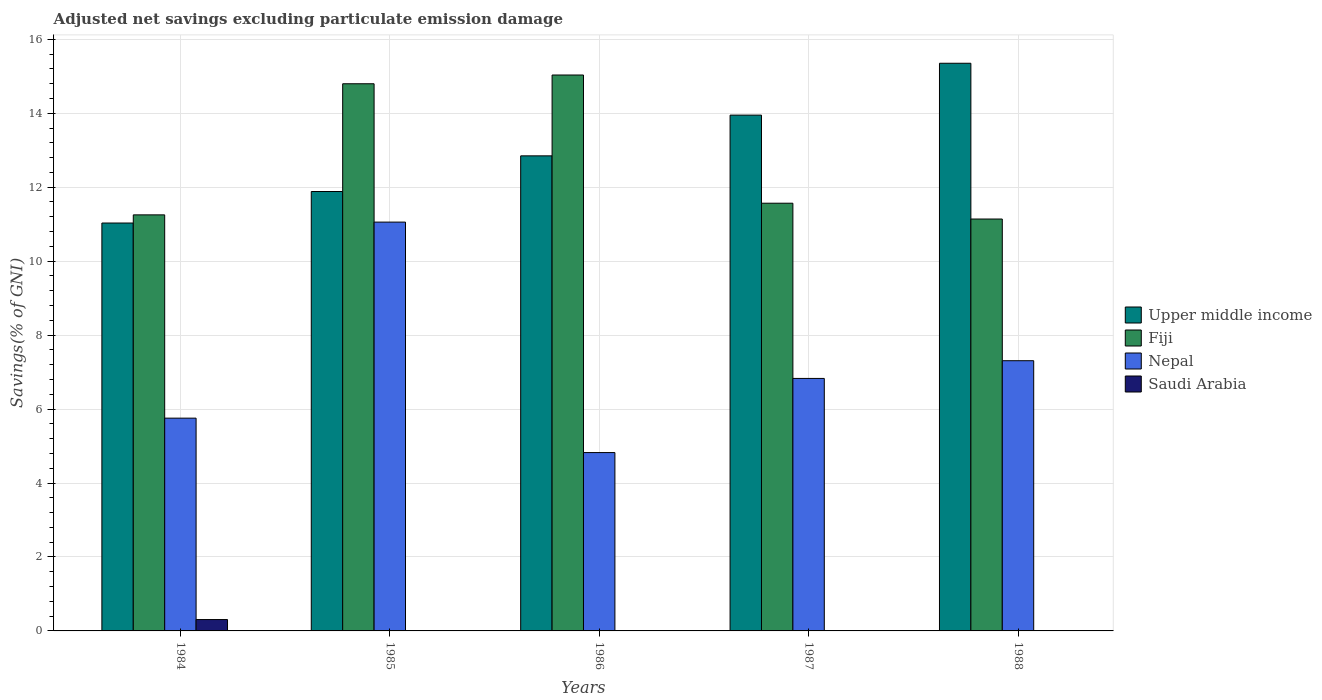How many groups of bars are there?
Give a very brief answer. 5. Are the number of bars per tick equal to the number of legend labels?
Offer a very short reply. No. Are the number of bars on each tick of the X-axis equal?
Keep it short and to the point. No. In how many cases, is the number of bars for a given year not equal to the number of legend labels?
Ensure brevity in your answer.  4. What is the adjusted net savings in Fiji in 1988?
Provide a succinct answer. 11.14. Across all years, what is the maximum adjusted net savings in Fiji?
Your response must be concise. 15.03. Across all years, what is the minimum adjusted net savings in Nepal?
Your answer should be compact. 4.82. In which year was the adjusted net savings in Nepal maximum?
Ensure brevity in your answer.  1985. What is the total adjusted net savings in Fiji in the graph?
Your answer should be very brief. 63.79. What is the difference between the adjusted net savings in Nepal in 1985 and that in 1988?
Provide a short and direct response. 3.75. What is the difference between the adjusted net savings in Saudi Arabia in 1986 and the adjusted net savings in Nepal in 1987?
Offer a very short reply. -6.83. What is the average adjusted net savings in Nepal per year?
Your answer should be compact. 7.15. In the year 1986, what is the difference between the adjusted net savings in Nepal and adjusted net savings in Upper middle income?
Your answer should be compact. -8.02. In how many years, is the adjusted net savings in Upper middle income greater than 11.6 %?
Your answer should be very brief. 4. What is the ratio of the adjusted net savings in Upper middle income in 1984 to that in 1988?
Ensure brevity in your answer.  0.72. Is the difference between the adjusted net savings in Nepal in 1985 and 1988 greater than the difference between the adjusted net savings in Upper middle income in 1985 and 1988?
Keep it short and to the point. Yes. What is the difference between the highest and the second highest adjusted net savings in Nepal?
Provide a short and direct response. 3.75. What is the difference between the highest and the lowest adjusted net savings in Upper middle income?
Provide a succinct answer. 4.32. Is the sum of the adjusted net savings in Upper middle income in 1985 and 1986 greater than the maximum adjusted net savings in Nepal across all years?
Ensure brevity in your answer.  Yes. How many bars are there?
Give a very brief answer. 16. Are all the bars in the graph horizontal?
Keep it short and to the point. No. What is the difference between two consecutive major ticks on the Y-axis?
Provide a succinct answer. 2. Does the graph contain grids?
Offer a very short reply. Yes. Where does the legend appear in the graph?
Provide a short and direct response. Center right. How many legend labels are there?
Make the answer very short. 4. What is the title of the graph?
Offer a very short reply. Adjusted net savings excluding particulate emission damage. Does "Sao Tome and Principe" appear as one of the legend labels in the graph?
Offer a terse response. No. What is the label or title of the Y-axis?
Your answer should be compact. Savings(% of GNI). What is the Savings(% of GNI) of Upper middle income in 1984?
Your answer should be very brief. 11.03. What is the Savings(% of GNI) in Fiji in 1984?
Keep it short and to the point. 11.25. What is the Savings(% of GNI) of Nepal in 1984?
Your response must be concise. 5.75. What is the Savings(% of GNI) in Saudi Arabia in 1984?
Offer a terse response. 0.31. What is the Savings(% of GNI) in Upper middle income in 1985?
Ensure brevity in your answer.  11.88. What is the Savings(% of GNI) of Fiji in 1985?
Provide a succinct answer. 14.8. What is the Savings(% of GNI) in Nepal in 1985?
Ensure brevity in your answer.  11.06. What is the Savings(% of GNI) of Saudi Arabia in 1985?
Ensure brevity in your answer.  0. What is the Savings(% of GNI) in Upper middle income in 1986?
Give a very brief answer. 12.85. What is the Savings(% of GNI) of Fiji in 1986?
Offer a terse response. 15.03. What is the Savings(% of GNI) in Nepal in 1986?
Give a very brief answer. 4.82. What is the Savings(% of GNI) in Saudi Arabia in 1986?
Provide a short and direct response. 0. What is the Savings(% of GNI) in Upper middle income in 1987?
Keep it short and to the point. 13.95. What is the Savings(% of GNI) in Fiji in 1987?
Provide a succinct answer. 11.57. What is the Savings(% of GNI) in Nepal in 1987?
Keep it short and to the point. 6.83. What is the Savings(% of GNI) of Upper middle income in 1988?
Offer a very short reply. 15.35. What is the Savings(% of GNI) in Fiji in 1988?
Your answer should be compact. 11.14. What is the Savings(% of GNI) in Nepal in 1988?
Provide a succinct answer. 7.31. What is the Savings(% of GNI) in Saudi Arabia in 1988?
Your answer should be compact. 0. Across all years, what is the maximum Savings(% of GNI) in Upper middle income?
Your response must be concise. 15.35. Across all years, what is the maximum Savings(% of GNI) of Fiji?
Provide a short and direct response. 15.03. Across all years, what is the maximum Savings(% of GNI) of Nepal?
Your answer should be very brief. 11.06. Across all years, what is the maximum Savings(% of GNI) of Saudi Arabia?
Ensure brevity in your answer.  0.31. Across all years, what is the minimum Savings(% of GNI) in Upper middle income?
Give a very brief answer. 11.03. Across all years, what is the minimum Savings(% of GNI) of Fiji?
Your response must be concise. 11.14. Across all years, what is the minimum Savings(% of GNI) of Nepal?
Your answer should be very brief. 4.82. Across all years, what is the minimum Savings(% of GNI) of Saudi Arabia?
Keep it short and to the point. 0. What is the total Savings(% of GNI) of Upper middle income in the graph?
Keep it short and to the point. 65.07. What is the total Savings(% of GNI) in Fiji in the graph?
Your answer should be very brief. 63.79. What is the total Savings(% of GNI) in Nepal in the graph?
Make the answer very short. 35.77. What is the total Savings(% of GNI) of Saudi Arabia in the graph?
Provide a short and direct response. 0.31. What is the difference between the Savings(% of GNI) of Upper middle income in 1984 and that in 1985?
Offer a very short reply. -0.85. What is the difference between the Savings(% of GNI) of Fiji in 1984 and that in 1985?
Offer a terse response. -3.55. What is the difference between the Savings(% of GNI) of Nepal in 1984 and that in 1985?
Provide a short and direct response. -5.3. What is the difference between the Savings(% of GNI) of Upper middle income in 1984 and that in 1986?
Your response must be concise. -1.82. What is the difference between the Savings(% of GNI) of Fiji in 1984 and that in 1986?
Offer a very short reply. -3.78. What is the difference between the Savings(% of GNI) in Nepal in 1984 and that in 1986?
Keep it short and to the point. 0.93. What is the difference between the Savings(% of GNI) in Upper middle income in 1984 and that in 1987?
Ensure brevity in your answer.  -2.92. What is the difference between the Savings(% of GNI) of Fiji in 1984 and that in 1987?
Offer a very short reply. -0.32. What is the difference between the Savings(% of GNI) of Nepal in 1984 and that in 1987?
Your answer should be very brief. -1.07. What is the difference between the Savings(% of GNI) in Upper middle income in 1984 and that in 1988?
Give a very brief answer. -4.32. What is the difference between the Savings(% of GNI) in Fiji in 1984 and that in 1988?
Provide a short and direct response. 0.11. What is the difference between the Savings(% of GNI) in Nepal in 1984 and that in 1988?
Make the answer very short. -1.55. What is the difference between the Savings(% of GNI) in Upper middle income in 1985 and that in 1986?
Give a very brief answer. -0.96. What is the difference between the Savings(% of GNI) in Fiji in 1985 and that in 1986?
Your answer should be very brief. -0.24. What is the difference between the Savings(% of GNI) in Nepal in 1985 and that in 1986?
Give a very brief answer. 6.23. What is the difference between the Savings(% of GNI) of Upper middle income in 1985 and that in 1987?
Provide a short and direct response. -2.07. What is the difference between the Savings(% of GNI) in Fiji in 1985 and that in 1987?
Your answer should be compact. 3.23. What is the difference between the Savings(% of GNI) in Nepal in 1985 and that in 1987?
Offer a terse response. 4.23. What is the difference between the Savings(% of GNI) of Upper middle income in 1985 and that in 1988?
Your response must be concise. -3.47. What is the difference between the Savings(% of GNI) in Fiji in 1985 and that in 1988?
Your answer should be very brief. 3.66. What is the difference between the Savings(% of GNI) of Nepal in 1985 and that in 1988?
Your answer should be compact. 3.75. What is the difference between the Savings(% of GNI) of Upper middle income in 1986 and that in 1987?
Your answer should be very brief. -1.1. What is the difference between the Savings(% of GNI) of Fiji in 1986 and that in 1987?
Your answer should be compact. 3.47. What is the difference between the Savings(% of GNI) in Nepal in 1986 and that in 1987?
Ensure brevity in your answer.  -2.01. What is the difference between the Savings(% of GNI) of Upper middle income in 1986 and that in 1988?
Keep it short and to the point. -2.5. What is the difference between the Savings(% of GNI) of Fiji in 1986 and that in 1988?
Provide a short and direct response. 3.89. What is the difference between the Savings(% of GNI) of Nepal in 1986 and that in 1988?
Your answer should be compact. -2.48. What is the difference between the Savings(% of GNI) in Upper middle income in 1987 and that in 1988?
Your answer should be compact. -1.4. What is the difference between the Savings(% of GNI) of Fiji in 1987 and that in 1988?
Ensure brevity in your answer.  0.43. What is the difference between the Savings(% of GNI) in Nepal in 1987 and that in 1988?
Offer a terse response. -0.48. What is the difference between the Savings(% of GNI) of Upper middle income in 1984 and the Savings(% of GNI) of Fiji in 1985?
Your answer should be very brief. -3.77. What is the difference between the Savings(% of GNI) in Upper middle income in 1984 and the Savings(% of GNI) in Nepal in 1985?
Your answer should be compact. -0.02. What is the difference between the Savings(% of GNI) in Fiji in 1984 and the Savings(% of GNI) in Nepal in 1985?
Provide a succinct answer. 0.2. What is the difference between the Savings(% of GNI) in Upper middle income in 1984 and the Savings(% of GNI) in Fiji in 1986?
Your response must be concise. -4. What is the difference between the Savings(% of GNI) of Upper middle income in 1984 and the Savings(% of GNI) of Nepal in 1986?
Your response must be concise. 6.21. What is the difference between the Savings(% of GNI) in Fiji in 1984 and the Savings(% of GNI) in Nepal in 1986?
Offer a very short reply. 6.43. What is the difference between the Savings(% of GNI) in Upper middle income in 1984 and the Savings(% of GNI) in Fiji in 1987?
Offer a very short reply. -0.54. What is the difference between the Savings(% of GNI) in Upper middle income in 1984 and the Savings(% of GNI) in Nepal in 1987?
Your answer should be compact. 4.2. What is the difference between the Savings(% of GNI) of Fiji in 1984 and the Savings(% of GNI) of Nepal in 1987?
Provide a short and direct response. 4.42. What is the difference between the Savings(% of GNI) of Upper middle income in 1984 and the Savings(% of GNI) of Fiji in 1988?
Provide a short and direct response. -0.11. What is the difference between the Savings(% of GNI) in Upper middle income in 1984 and the Savings(% of GNI) in Nepal in 1988?
Your answer should be very brief. 3.72. What is the difference between the Savings(% of GNI) of Fiji in 1984 and the Savings(% of GNI) of Nepal in 1988?
Your answer should be compact. 3.94. What is the difference between the Savings(% of GNI) in Upper middle income in 1985 and the Savings(% of GNI) in Fiji in 1986?
Provide a short and direct response. -3.15. What is the difference between the Savings(% of GNI) of Upper middle income in 1985 and the Savings(% of GNI) of Nepal in 1986?
Give a very brief answer. 7.06. What is the difference between the Savings(% of GNI) of Fiji in 1985 and the Savings(% of GNI) of Nepal in 1986?
Offer a very short reply. 9.97. What is the difference between the Savings(% of GNI) in Upper middle income in 1985 and the Savings(% of GNI) in Fiji in 1987?
Offer a terse response. 0.32. What is the difference between the Savings(% of GNI) in Upper middle income in 1985 and the Savings(% of GNI) in Nepal in 1987?
Your answer should be compact. 5.06. What is the difference between the Savings(% of GNI) of Fiji in 1985 and the Savings(% of GNI) of Nepal in 1987?
Ensure brevity in your answer.  7.97. What is the difference between the Savings(% of GNI) of Upper middle income in 1985 and the Savings(% of GNI) of Fiji in 1988?
Your answer should be very brief. 0.74. What is the difference between the Savings(% of GNI) of Upper middle income in 1985 and the Savings(% of GNI) of Nepal in 1988?
Provide a short and direct response. 4.58. What is the difference between the Savings(% of GNI) in Fiji in 1985 and the Savings(% of GNI) in Nepal in 1988?
Keep it short and to the point. 7.49. What is the difference between the Savings(% of GNI) in Upper middle income in 1986 and the Savings(% of GNI) in Fiji in 1987?
Give a very brief answer. 1.28. What is the difference between the Savings(% of GNI) in Upper middle income in 1986 and the Savings(% of GNI) in Nepal in 1987?
Keep it short and to the point. 6.02. What is the difference between the Savings(% of GNI) of Fiji in 1986 and the Savings(% of GNI) of Nepal in 1987?
Provide a short and direct response. 8.21. What is the difference between the Savings(% of GNI) of Upper middle income in 1986 and the Savings(% of GNI) of Fiji in 1988?
Provide a succinct answer. 1.71. What is the difference between the Savings(% of GNI) of Upper middle income in 1986 and the Savings(% of GNI) of Nepal in 1988?
Provide a short and direct response. 5.54. What is the difference between the Savings(% of GNI) in Fiji in 1986 and the Savings(% of GNI) in Nepal in 1988?
Your answer should be compact. 7.73. What is the difference between the Savings(% of GNI) in Upper middle income in 1987 and the Savings(% of GNI) in Fiji in 1988?
Your answer should be compact. 2.81. What is the difference between the Savings(% of GNI) in Upper middle income in 1987 and the Savings(% of GNI) in Nepal in 1988?
Ensure brevity in your answer.  6.64. What is the difference between the Savings(% of GNI) of Fiji in 1987 and the Savings(% of GNI) of Nepal in 1988?
Your answer should be very brief. 4.26. What is the average Savings(% of GNI) in Upper middle income per year?
Ensure brevity in your answer.  13.01. What is the average Savings(% of GNI) of Fiji per year?
Your answer should be compact. 12.76. What is the average Savings(% of GNI) of Nepal per year?
Your answer should be compact. 7.15. What is the average Savings(% of GNI) of Saudi Arabia per year?
Make the answer very short. 0.06. In the year 1984, what is the difference between the Savings(% of GNI) of Upper middle income and Savings(% of GNI) of Fiji?
Your response must be concise. -0.22. In the year 1984, what is the difference between the Savings(% of GNI) of Upper middle income and Savings(% of GNI) of Nepal?
Offer a terse response. 5.28. In the year 1984, what is the difference between the Savings(% of GNI) of Upper middle income and Savings(% of GNI) of Saudi Arabia?
Ensure brevity in your answer.  10.72. In the year 1984, what is the difference between the Savings(% of GNI) of Fiji and Savings(% of GNI) of Nepal?
Your response must be concise. 5.5. In the year 1984, what is the difference between the Savings(% of GNI) in Fiji and Savings(% of GNI) in Saudi Arabia?
Provide a short and direct response. 10.94. In the year 1984, what is the difference between the Savings(% of GNI) in Nepal and Savings(% of GNI) in Saudi Arabia?
Make the answer very short. 5.45. In the year 1985, what is the difference between the Savings(% of GNI) of Upper middle income and Savings(% of GNI) of Fiji?
Offer a terse response. -2.91. In the year 1985, what is the difference between the Savings(% of GNI) in Upper middle income and Savings(% of GNI) in Nepal?
Your answer should be very brief. 0.83. In the year 1985, what is the difference between the Savings(% of GNI) in Fiji and Savings(% of GNI) in Nepal?
Your answer should be very brief. 3.74. In the year 1986, what is the difference between the Savings(% of GNI) of Upper middle income and Savings(% of GNI) of Fiji?
Offer a terse response. -2.19. In the year 1986, what is the difference between the Savings(% of GNI) of Upper middle income and Savings(% of GNI) of Nepal?
Keep it short and to the point. 8.02. In the year 1986, what is the difference between the Savings(% of GNI) of Fiji and Savings(% of GNI) of Nepal?
Your answer should be compact. 10.21. In the year 1987, what is the difference between the Savings(% of GNI) of Upper middle income and Savings(% of GNI) of Fiji?
Ensure brevity in your answer.  2.38. In the year 1987, what is the difference between the Savings(% of GNI) in Upper middle income and Savings(% of GNI) in Nepal?
Make the answer very short. 7.12. In the year 1987, what is the difference between the Savings(% of GNI) in Fiji and Savings(% of GNI) in Nepal?
Your answer should be very brief. 4.74. In the year 1988, what is the difference between the Savings(% of GNI) of Upper middle income and Savings(% of GNI) of Fiji?
Provide a succinct answer. 4.21. In the year 1988, what is the difference between the Savings(% of GNI) in Upper middle income and Savings(% of GNI) in Nepal?
Keep it short and to the point. 8.04. In the year 1988, what is the difference between the Savings(% of GNI) in Fiji and Savings(% of GNI) in Nepal?
Offer a very short reply. 3.83. What is the ratio of the Savings(% of GNI) of Upper middle income in 1984 to that in 1985?
Your answer should be very brief. 0.93. What is the ratio of the Savings(% of GNI) in Fiji in 1984 to that in 1985?
Your answer should be very brief. 0.76. What is the ratio of the Savings(% of GNI) in Nepal in 1984 to that in 1985?
Your answer should be compact. 0.52. What is the ratio of the Savings(% of GNI) of Upper middle income in 1984 to that in 1986?
Provide a succinct answer. 0.86. What is the ratio of the Savings(% of GNI) of Fiji in 1984 to that in 1986?
Your answer should be very brief. 0.75. What is the ratio of the Savings(% of GNI) of Nepal in 1984 to that in 1986?
Provide a short and direct response. 1.19. What is the ratio of the Savings(% of GNI) in Upper middle income in 1984 to that in 1987?
Your response must be concise. 0.79. What is the ratio of the Savings(% of GNI) of Fiji in 1984 to that in 1987?
Keep it short and to the point. 0.97. What is the ratio of the Savings(% of GNI) in Nepal in 1984 to that in 1987?
Offer a very short reply. 0.84. What is the ratio of the Savings(% of GNI) of Upper middle income in 1984 to that in 1988?
Your response must be concise. 0.72. What is the ratio of the Savings(% of GNI) of Fiji in 1984 to that in 1988?
Provide a succinct answer. 1.01. What is the ratio of the Savings(% of GNI) of Nepal in 1984 to that in 1988?
Your response must be concise. 0.79. What is the ratio of the Savings(% of GNI) in Upper middle income in 1985 to that in 1986?
Your answer should be compact. 0.93. What is the ratio of the Savings(% of GNI) of Fiji in 1985 to that in 1986?
Your answer should be very brief. 0.98. What is the ratio of the Savings(% of GNI) of Nepal in 1985 to that in 1986?
Your response must be concise. 2.29. What is the ratio of the Savings(% of GNI) of Upper middle income in 1985 to that in 1987?
Offer a terse response. 0.85. What is the ratio of the Savings(% of GNI) of Fiji in 1985 to that in 1987?
Ensure brevity in your answer.  1.28. What is the ratio of the Savings(% of GNI) in Nepal in 1985 to that in 1987?
Offer a very short reply. 1.62. What is the ratio of the Savings(% of GNI) of Upper middle income in 1985 to that in 1988?
Provide a succinct answer. 0.77. What is the ratio of the Savings(% of GNI) in Fiji in 1985 to that in 1988?
Give a very brief answer. 1.33. What is the ratio of the Savings(% of GNI) in Nepal in 1985 to that in 1988?
Provide a short and direct response. 1.51. What is the ratio of the Savings(% of GNI) of Upper middle income in 1986 to that in 1987?
Provide a succinct answer. 0.92. What is the ratio of the Savings(% of GNI) in Fiji in 1986 to that in 1987?
Your answer should be compact. 1.3. What is the ratio of the Savings(% of GNI) of Nepal in 1986 to that in 1987?
Your response must be concise. 0.71. What is the ratio of the Savings(% of GNI) in Upper middle income in 1986 to that in 1988?
Your response must be concise. 0.84. What is the ratio of the Savings(% of GNI) in Fiji in 1986 to that in 1988?
Give a very brief answer. 1.35. What is the ratio of the Savings(% of GNI) in Nepal in 1986 to that in 1988?
Your answer should be compact. 0.66. What is the ratio of the Savings(% of GNI) of Upper middle income in 1987 to that in 1988?
Your answer should be compact. 0.91. What is the ratio of the Savings(% of GNI) in Fiji in 1987 to that in 1988?
Offer a terse response. 1.04. What is the ratio of the Savings(% of GNI) of Nepal in 1987 to that in 1988?
Give a very brief answer. 0.93. What is the difference between the highest and the second highest Savings(% of GNI) of Upper middle income?
Provide a short and direct response. 1.4. What is the difference between the highest and the second highest Savings(% of GNI) of Fiji?
Offer a terse response. 0.24. What is the difference between the highest and the second highest Savings(% of GNI) in Nepal?
Your answer should be very brief. 3.75. What is the difference between the highest and the lowest Savings(% of GNI) of Upper middle income?
Offer a terse response. 4.32. What is the difference between the highest and the lowest Savings(% of GNI) of Fiji?
Offer a very short reply. 3.89. What is the difference between the highest and the lowest Savings(% of GNI) of Nepal?
Offer a very short reply. 6.23. What is the difference between the highest and the lowest Savings(% of GNI) in Saudi Arabia?
Offer a very short reply. 0.31. 